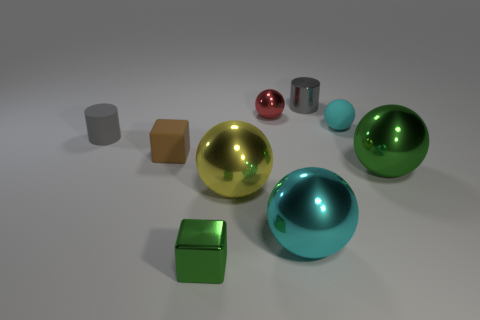Are there any blue metallic objects that have the same size as the red thing?
Provide a succinct answer. No. What is the material of the red ball that is the same size as the gray matte cylinder?
Offer a very short reply. Metal. The large object that is both left of the green metal ball and to the right of the large yellow sphere has what shape?
Your answer should be very brief. Sphere. The tiny thing in front of the green metal sphere is what color?
Your answer should be very brief. Green. What size is the metal object that is both behind the big yellow shiny object and in front of the gray matte thing?
Offer a very short reply. Large. Are the tiny brown thing and the sphere to the right of the small cyan sphere made of the same material?
Make the answer very short. No. How many large objects have the same shape as the small gray rubber object?
Your answer should be very brief. 0. There is a thing that is the same color as the tiny shiny cylinder; what is it made of?
Make the answer very short. Rubber. What number of large spheres are there?
Your response must be concise. 3. Do the large green shiny object and the small red metal thing that is on the right side of the large yellow shiny thing have the same shape?
Ensure brevity in your answer.  Yes. 